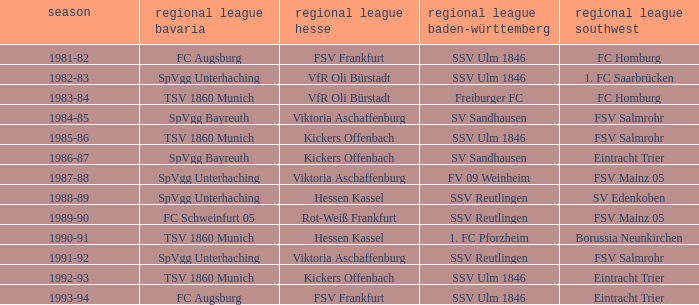Would you mind parsing the complete table? {'header': ['season', 'regional league bavaria', 'regional league hesse', 'regional league baden-württemberg', 'regional league southwest'], 'rows': [['1981-82', 'FC Augsburg', 'FSV Frankfurt', 'SSV Ulm 1846', 'FC Homburg'], ['1982-83', 'SpVgg Unterhaching', 'VfR Oli Bürstadt', 'SSV Ulm 1846', '1. FC Saarbrücken'], ['1983-84', 'TSV 1860 Munich', 'VfR Oli Bürstadt', 'Freiburger FC', 'FC Homburg'], ['1984-85', 'SpVgg Bayreuth', 'Viktoria Aschaffenburg', 'SV Sandhausen', 'FSV Salmrohr'], ['1985-86', 'TSV 1860 Munich', 'Kickers Offenbach', 'SSV Ulm 1846', 'FSV Salmrohr'], ['1986-87', 'SpVgg Bayreuth', 'Kickers Offenbach', 'SV Sandhausen', 'Eintracht Trier'], ['1987-88', 'SpVgg Unterhaching', 'Viktoria Aschaffenburg', 'FV 09 Weinheim', 'FSV Mainz 05'], ['1988-89', 'SpVgg Unterhaching', 'Hessen Kassel', 'SSV Reutlingen', 'SV Edenkoben'], ['1989-90', 'FC Schweinfurt 05', 'Rot-Weiß Frankfurt', 'SSV Reutlingen', 'FSV Mainz 05'], ['1990-91', 'TSV 1860 Munich', 'Hessen Kassel', '1. FC Pforzheim', 'Borussia Neunkirchen'], ['1991-92', 'SpVgg Unterhaching', 'Viktoria Aschaffenburg', 'SSV Reutlingen', 'FSV Salmrohr'], ['1992-93', 'TSV 1860 Munich', 'Kickers Offenbach', 'SSV Ulm 1846', 'Eintracht Trier'], ['1993-94', 'FC Augsburg', 'FSV Frankfurt', 'SSV Ulm 1846', 'Eintracht Trier']]} Which Oberliga Bayern has a Season of 1981-82? FC Augsburg. 